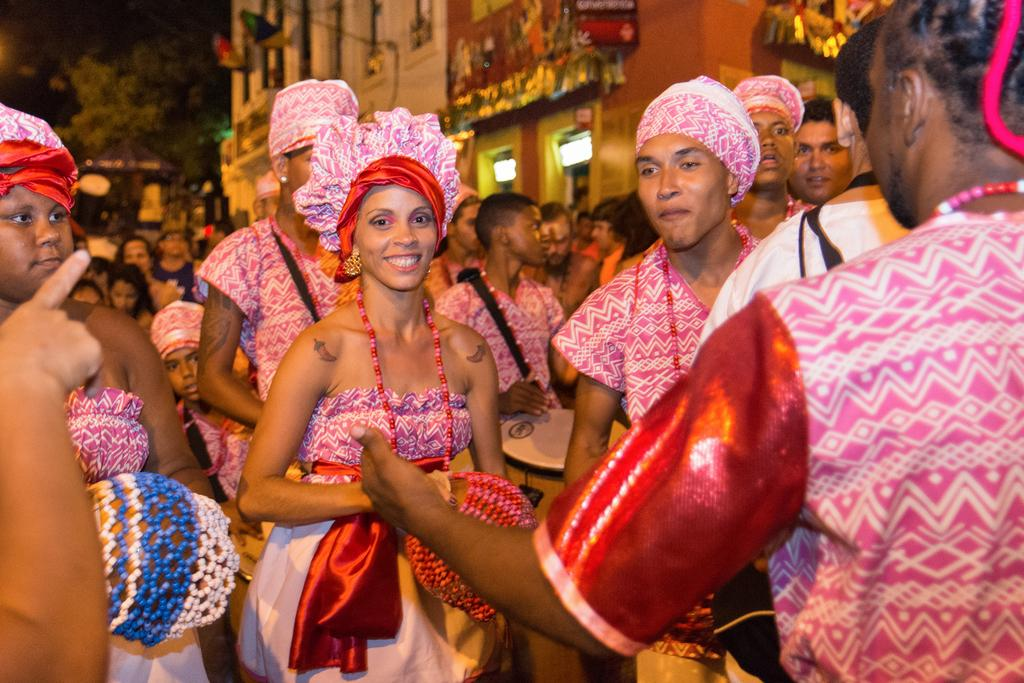What can be observed about the people in the image? There are people standing in the image, and they are wearing dresses. What is visible in the background of the image? There is a building in the background of the image. What type of vegetation is on the left side of the image? There are trees on the left side of the image. Where is the bone located in the image? There is no bone present in the image. What type of mailbox can be seen near the trees on the left side of the image? There is no mailbox present in the image; only trees are visible on the left side. 